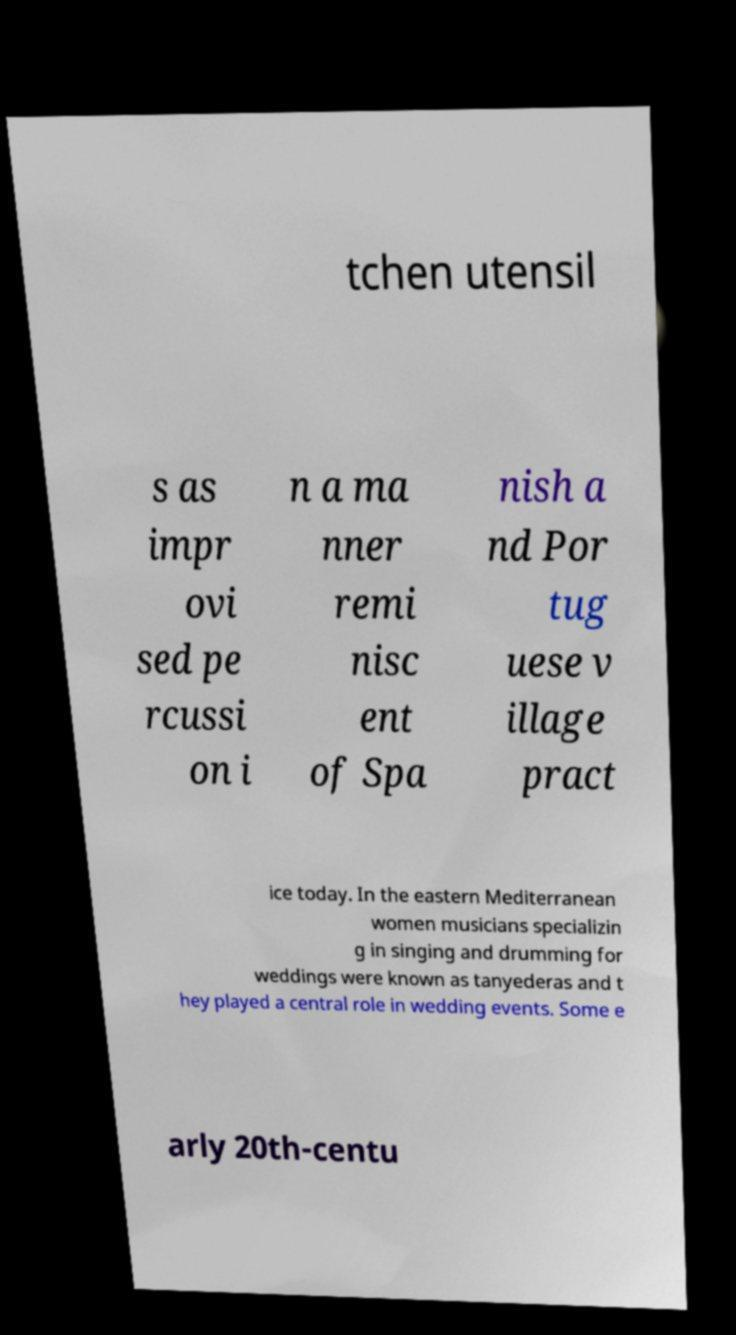Can you accurately transcribe the text from the provided image for me? tchen utensil s as impr ovi sed pe rcussi on i n a ma nner remi nisc ent of Spa nish a nd Por tug uese v illage pract ice today. In the eastern Mediterranean women musicians specializin g in singing and drumming for weddings were known as tanyederas and t hey played a central role in wedding events. Some e arly 20th-centu 